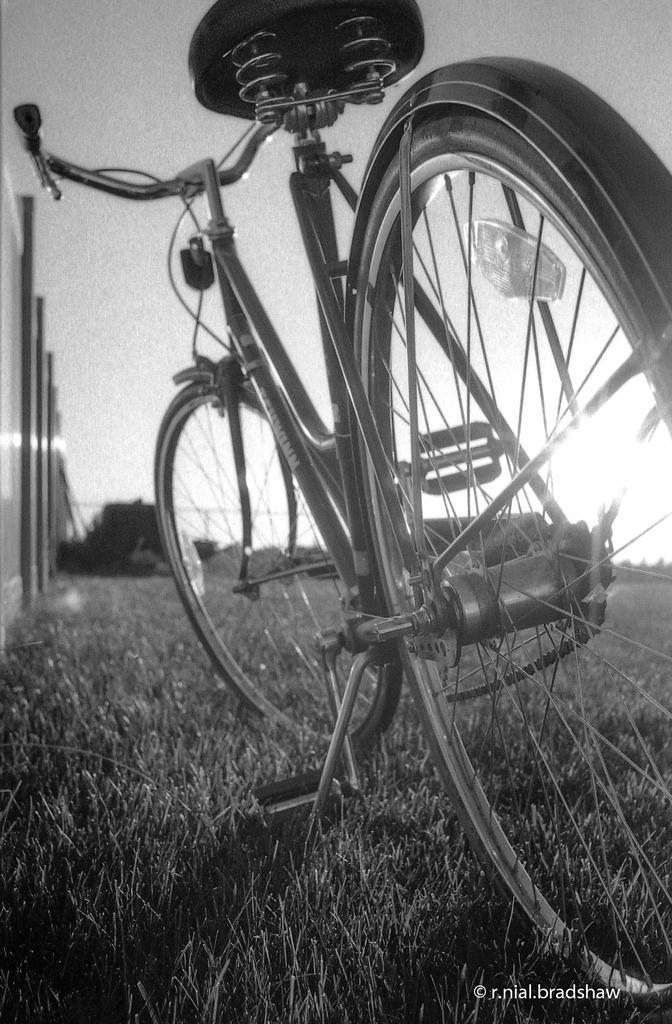Can you describe this image briefly? In the image we can see there is a bicycle which is parked on the ground and the ground is covered with grass. The image is in black and white colour. 